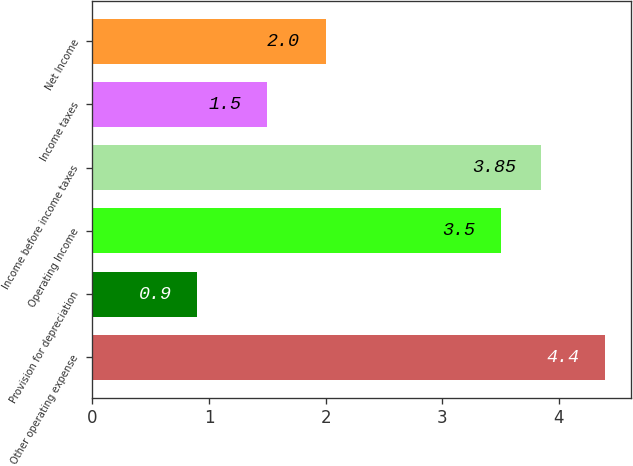Convert chart to OTSL. <chart><loc_0><loc_0><loc_500><loc_500><bar_chart><fcel>Other operating expense<fcel>Provision for depreciation<fcel>Operating Income<fcel>Income before income taxes<fcel>Income taxes<fcel>Net Income<nl><fcel>4.4<fcel>0.9<fcel>3.5<fcel>3.85<fcel>1.5<fcel>2<nl></chart> 